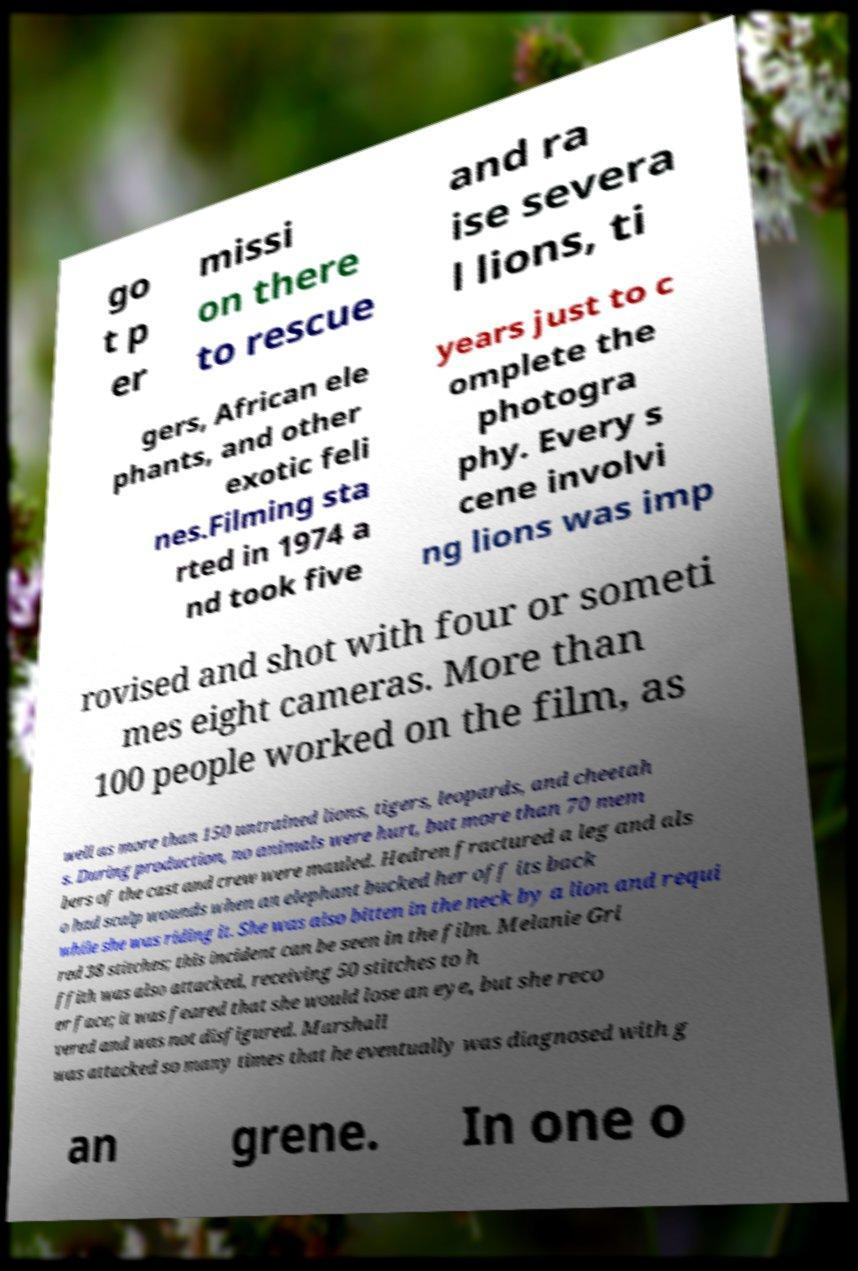Please identify and transcribe the text found in this image. go t p er missi on there to rescue and ra ise severa l lions, ti gers, African ele phants, and other exotic feli nes.Filming sta rted in 1974 a nd took five years just to c omplete the photogra phy. Every s cene involvi ng lions was imp rovised and shot with four or someti mes eight cameras. More than 100 people worked on the film, as well as more than 150 untrained lions, tigers, leopards, and cheetah s. During production, no animals were hurt, but more than 70 mem bers of the cast and crew were mauled. Hedren fractured a leg and als o had scalp wounds when an elephant bucked her off its back while she was riding it. She was also bitten in the neck by a lion and requi red 38 stitches; this incident can be seen in the film. Melanie Gri ffith was also attacked, receiving 50 stitches to h er face; it was feared that she would lose an eye, but she reco vered and was not disfigured. Marshall was attacked so many times that he eventually was diagnosed with g an grene. In one o 